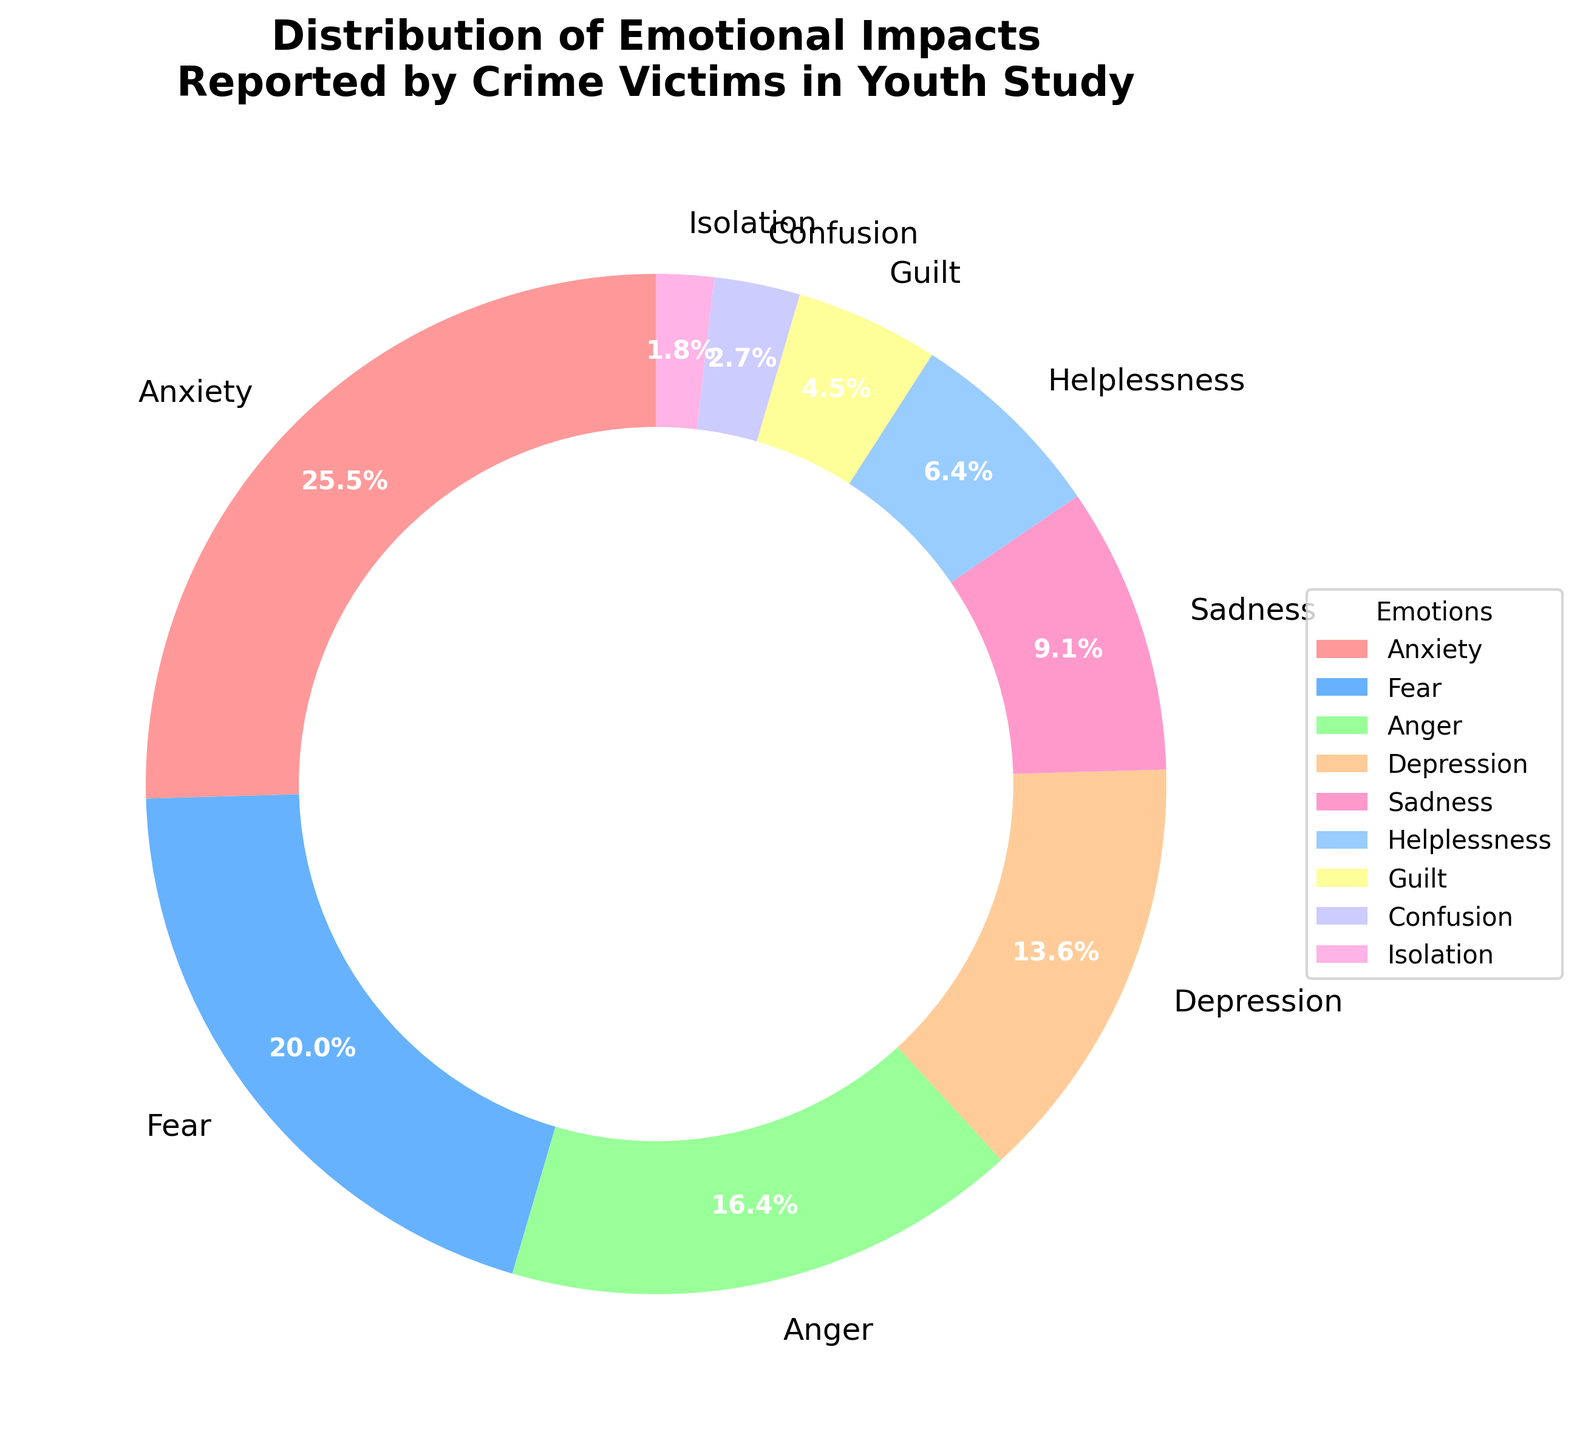what is the most reported emotional impact of crime among youths? The pie chart shows different emotional impacts along with their proportions. The slice labeled "Anxiety" occupies the largest portion of the pie, indicating that it is the most reported emotional impact.
Answer: Anxiety Which emotional impact is reported less: Helplessness or Confusion? The pie chart shows the percentages of each emotion. Helplessness is represented by 7% and Confusion by 3%. Since 7% is greater than 3%, Helplessness is reported more than Confusion, making Confusion reported less.
Answer: Confusion What is the total percentage of victims who reported Anxiety, Fear, and Anger combined? To find the total percentage, add the individual percentages for Anxiety, Fear, and Anger: 28% (Anxiety) + 22% (Fear) + 18% (Anger) = 68%.
Answer: 68% Which emotional impact has the smallest slice in the pie chart? By examining the slices in the pie chart and their corresponding labels, the slice for Isolation is the smallest, with a percentage of 2%.
Answer: Isolation Are the combined percentages of Depression and Sadness greater than that of Anxiety? Depression has 15% and Sadness has 10%. Adding these together (15% + 10% = 25%) and comparing it with Anxiety, which has 28%, we see that 25% is not greater than 28%.
Answer: No What is the difference in percentage between Anger and Guilt? From the pie chart, Anger is 18% and Guilt is 5%. The difference between these two percentages is 18% - 5% = 13%.
Answer: 13% How many emotional impacts have a percentage above 10%? By looking at each slice in the pie chart: Anxiety (28%), Fear (22%), Anger (18%), and Depression (15%) and Sadness (10%). There are five emotions with percentages at or above 10%.
Answer: Five 